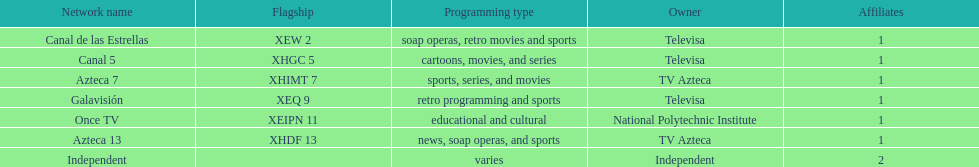Who is the only network possessor featured in a consecutive sequence in the chart? Televisa. 